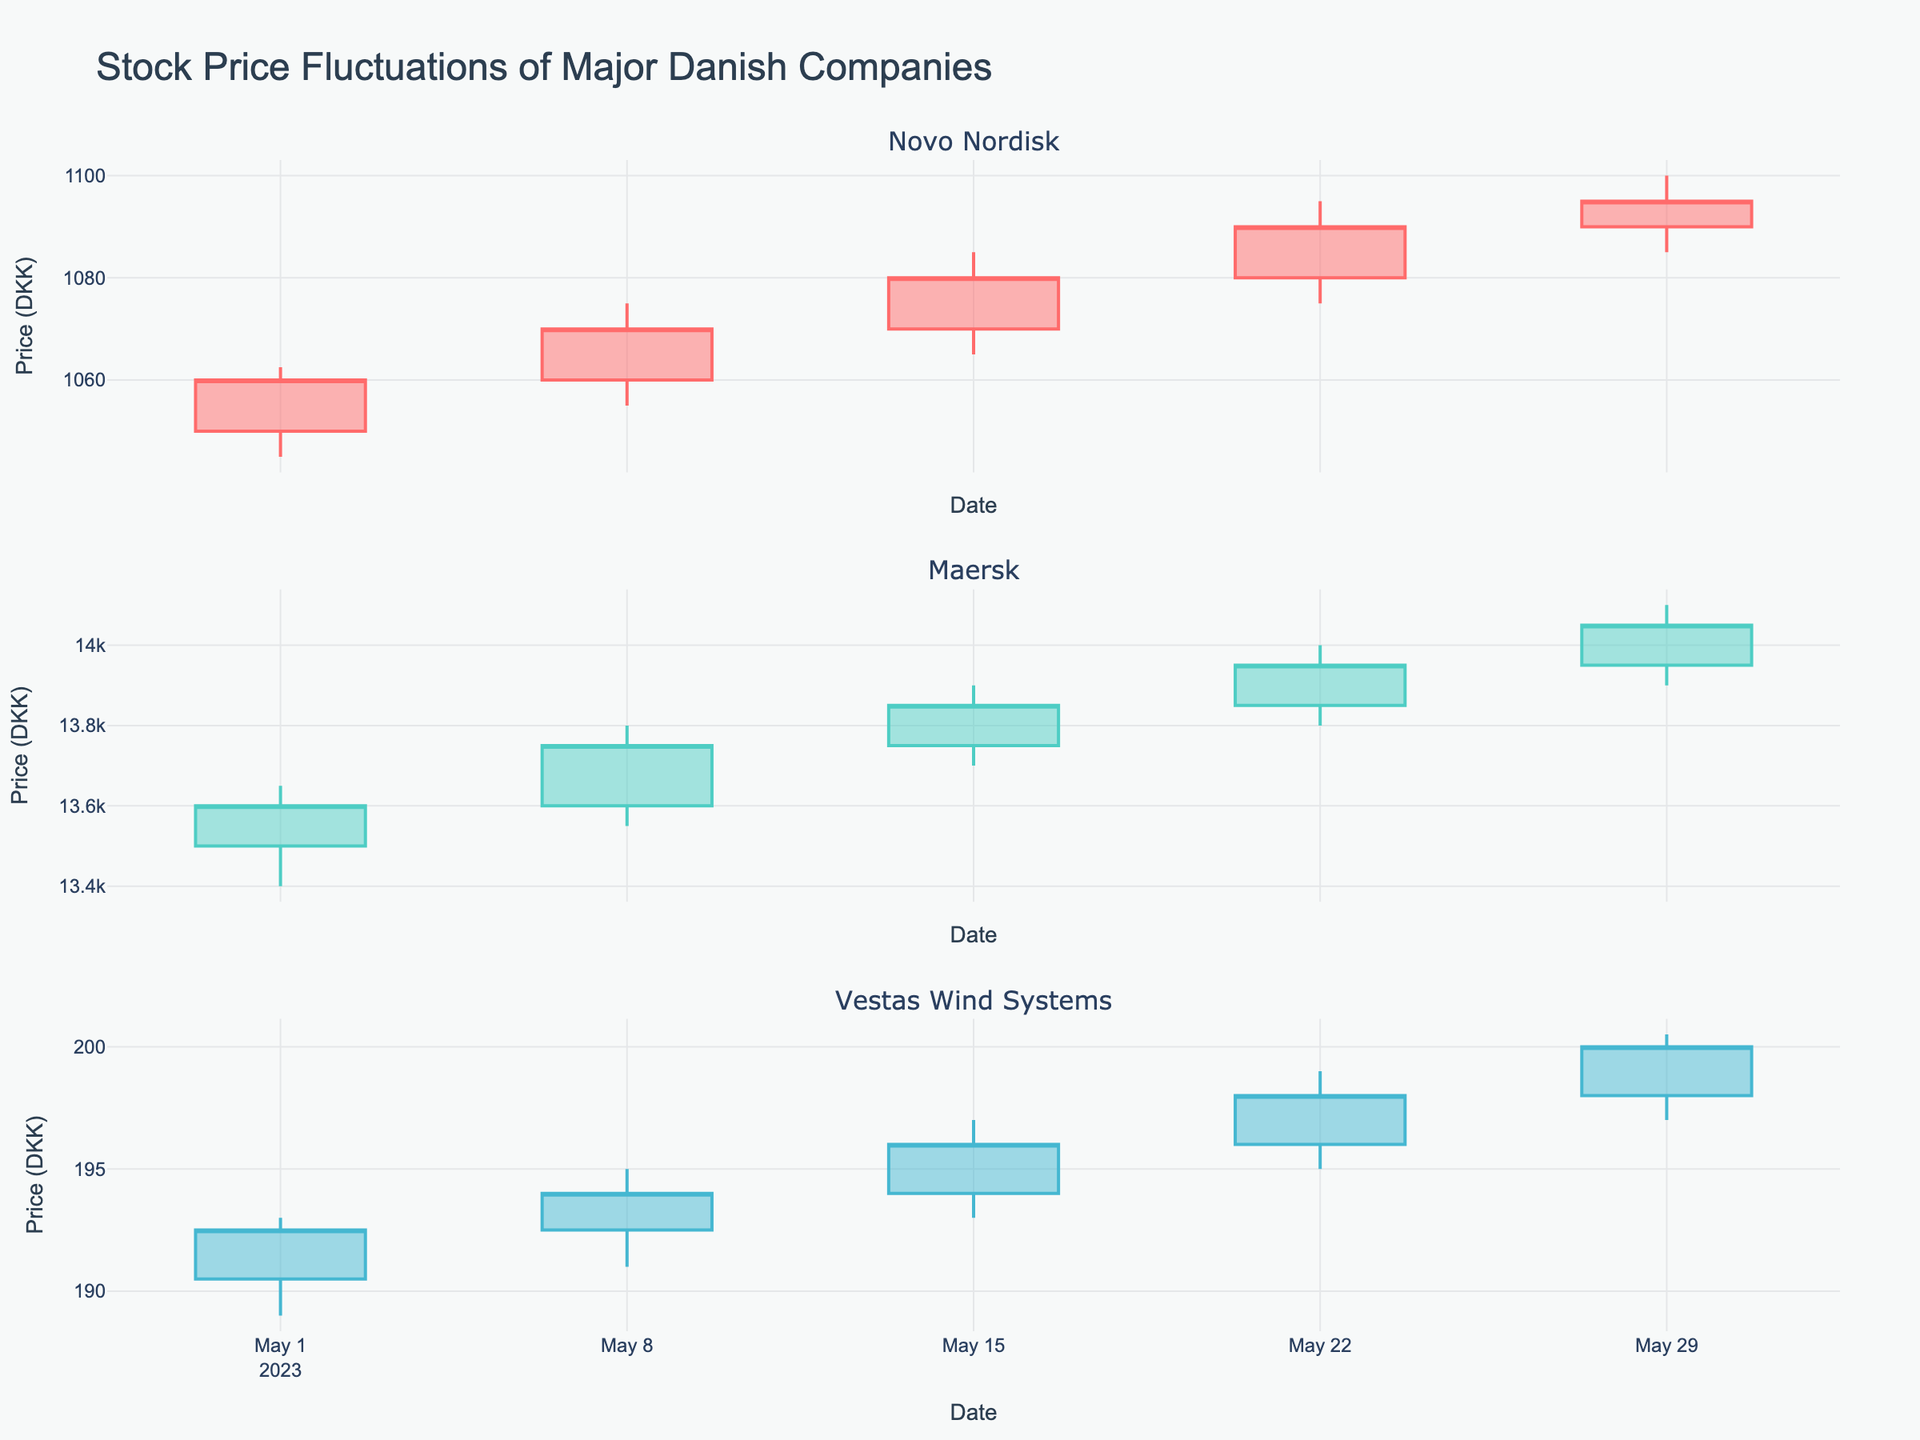What is the highest price that Maersk's stock reached in May 2023? From the figure, for Maersk, the highest high value within the month of May 2023 is observed on 2023-05-29, where the high value is 14100.00 DKK.
Answer: 14100.00 DKK What was Vestas Wind Systems's closing price on May 29, 2023? Looking at the OHLC chart for Vestas Wind Systems on May 29, 2023, the closing price is represented by the end of the vertical line, which is 200.00 DKK.
Answer: 200.00 DKK Which company had the highest closing price on May 22, 2023? By examining the closing prices for all three companies on May 22, 2023, Novo Nordisk closed at 1090.00 DKK, Maersk closed at 13950.00 DKK, and Vestas Wind Systems closed at 198.00 DKK. Maersk's closing price is the highest.
Answer: Maersk What is the trend in Novo Nordisk's stock price over the month of May 2023? Observing the OHLC plot for Novo Nordisk, the closing price increases consistently each week from 1060.00 DKK on 2023-05-01 to 1095.00 DKK on 2023-05-29, indicating an upward trend.
Answer: Upward trend How does Vestas Wind Systems' highest price for the month compare to Novo Nordisk's highest price for the month? Vestas Wind Systems' highest price in May is 200.50 DKK on 2023-05-29, while Novo Nordisk's highest price is 1100.00 DKK on 2023-05-29. Novo Nordisk's highest price is significantly higher.
Answer: Novo Nordisk's highest price is higher What is the average closing price of Maersk over the month? Maersk's closing prices over the month are 13600.00 DKK, 13750.00 DKK, 13850.00 DKK, 13950.00 DKK, and 14050.00 DKK. Summing these, we get 69200.00 DKK. Dividing by 5 weeks, the average is 13840.00 DKK.
Answer: 13840.00 DKK Which company showed the most volatility in its stock price during May 2023? Volatility can be judged by the range of high and low values. Vestas Wind Systems varies from a low of 189.00 DKK to a high of 200.50 DKK, Novo Nordisk from 1045.00 DKK to 1100.00 DKK, and Maersk from 13400.00 DKK to 14100.00 DKK. Maersk shows the widest range (700.00 DKK).
Answer: Maersk On which date was Vestas Wind Systems' opening price closest to its closing price? The smallest difference between opening and closing prices for Vestas can be calculated. On 2023-05-01, the difference is 2.00 DKK; on 2023-05-08, 1.50 DKK; on 2023-05-15, 2.00 DKK; on 2023-05-22, 2.00 DKK; and on 2023-05-29, 2.00 DKK. The smallest difference is on 2023-05-08 (1.50 DKK).
Answer: 2023-05-08 